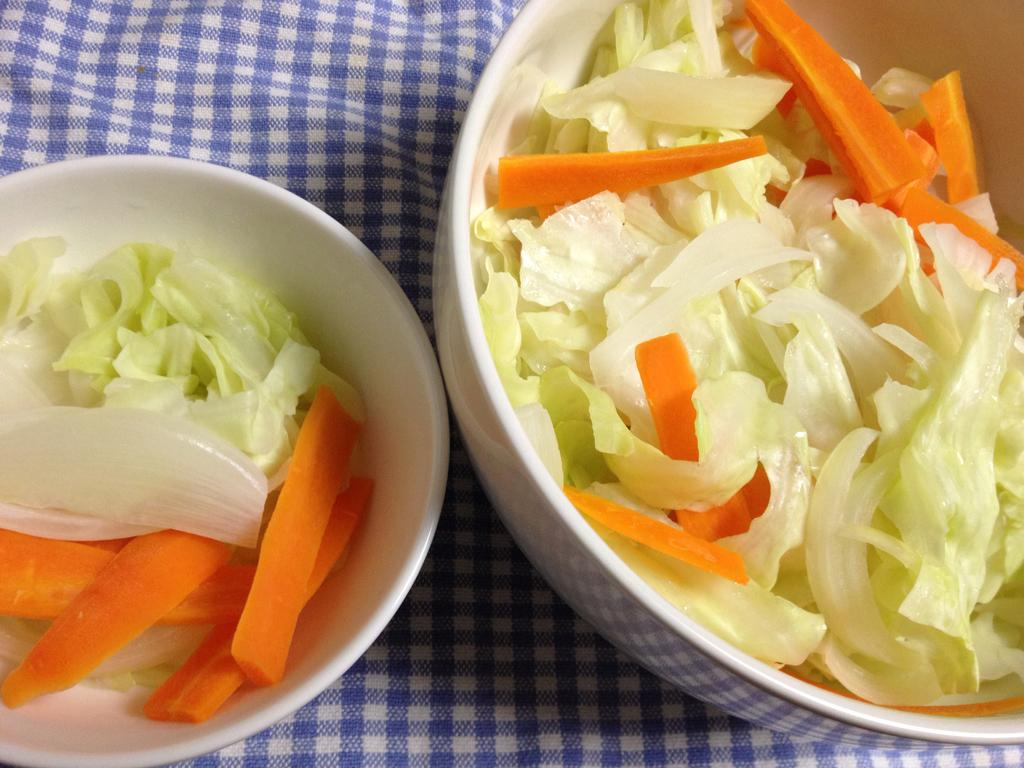What is in the bowls that are visible in the image? There is food in the bowls in the image. What might be used for cleaning or wiping in the image? A napkin is visible in the image for cleaning or wiping. How many trays are visible in the image? There is no tray present in the image. What type of produce can be seen in the image? There is no produce visible in the image. 